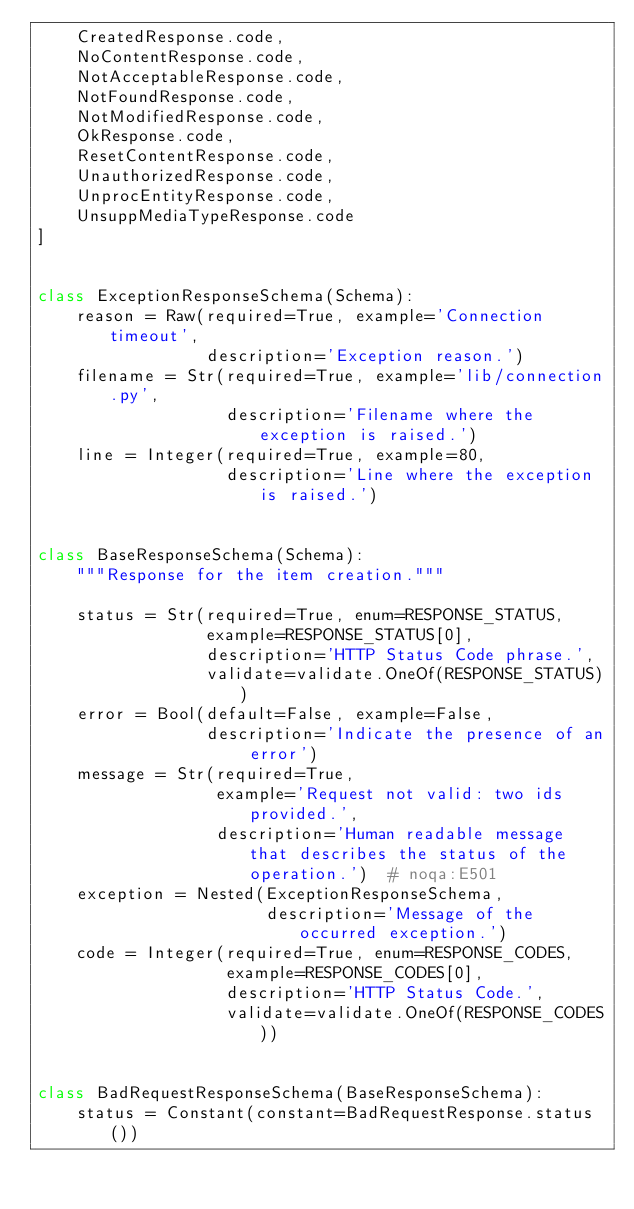<code> <loc_0><loc_0><loc_500><loc_500><_Python_>    CreatedResponse.code,
    NoContentResponse.code,
    NotAcceptableResponse.code,
    NotFoundResponse.code,
    NotModifiedResponse.code,
    OkResponse.code,
    ResetContentResponse.code,
    UnauthorizedResponse.code,
    UnprocEntityResponse.code,
    UnsuppMediaTypeResponse.code
]


class ExceptionResponseSchema(Schema):
    reason = Raw(required=True, example='Connection timeout',
                 description='Exception reason.')
    filename = Str(required=True, example='lib/connection.py',
                   description='Filename where the exception is raised.')
    line = Integer(required=True, example=80,
                   description='Line where the exception is raised.')


class BaseResponseSchema(Schema):
    """Response for the item creation."""

    status = Str(required=True, enum=RESPONSE_STATUS,
                 example=RESPONSE_STATUS[0],
                 description='HTTP Status Code phrase.',
                 validate=validate.OneOf(RESPONSE_STATUS))
    error = Bool(default=False, example=False,
                 description='Indicate the presence of an error')
    message = Str(required=True,
                  example='Request not valid: two ids provided.',
                  description='Human readable message that describes the status of the operation.')  # noqa:E501
    exception = Nested(ExceptionResponseSchema,
                       description='Message of the occurred exception.')
    code = Integer(required=True, enum=RESPONSE_CODES,
                   example=RESPONSE_CODES[0],
                   description='HTTP Status Code.',
                   validate=validate.OneOf(RESPONSE_CODES))


class BadRequestResponseSchema(BaseResponseSchema):
    status = Constant(constant=BadRequestResponse.status())</code> 